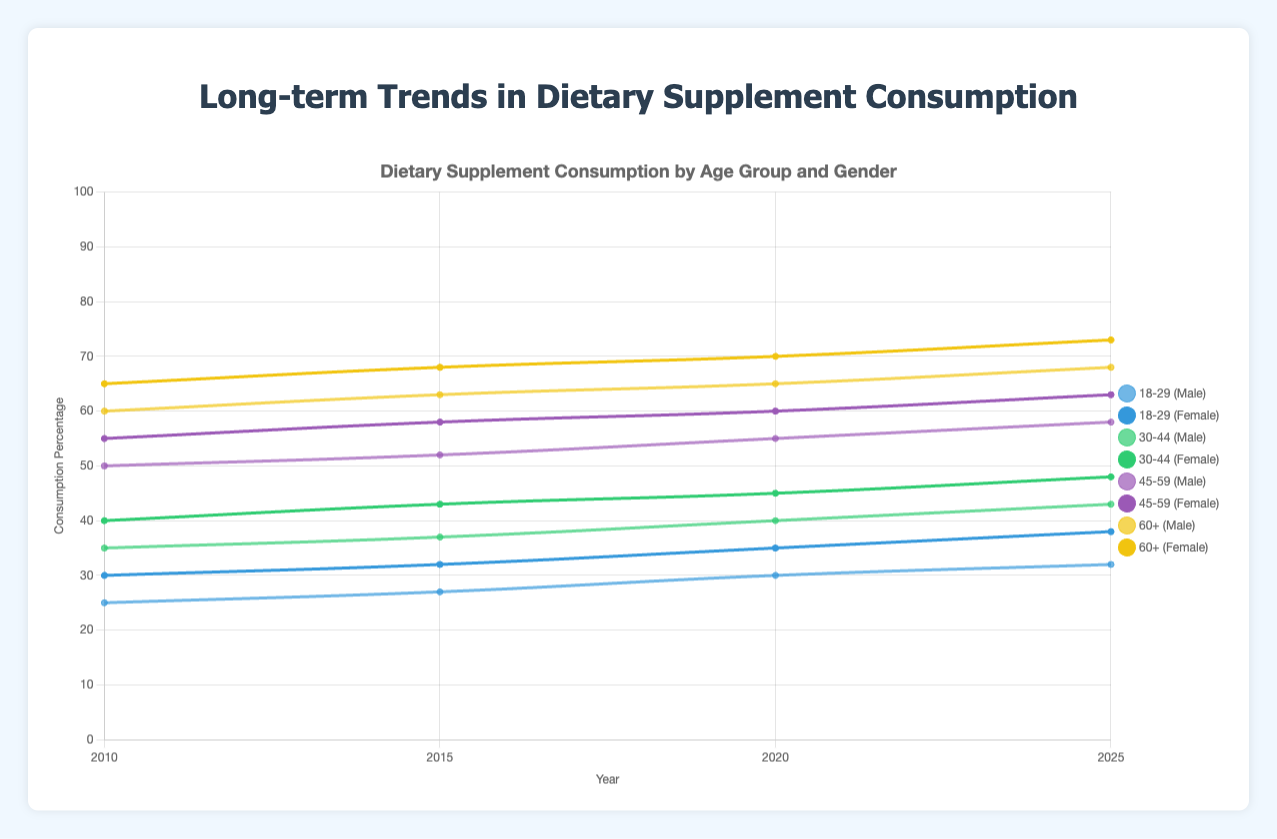Which gender showed the highest consumption percentage for the 60+ age group in 2020? Look at the 2020 data points for the 60+ age group. For males, the percentage is 65%, and for females, it is 70%.
Answer: Female By how many percentage points did dietary supplement consumption increase for the 18-29 age group males from 2010 to 2025? Find the consumption percentage for 18-29 males in 2010 (25%) and 2025 (32%), then subtract the former from the latter: 32% - 25% = 7%.
Answer: 7 What is the average consumption percentage of dietary supplements for all age groups and genders in 2025? Average the 2025 consumption percentages for all entries: (32 + 38 + 43 + 48 + 58 + 63 + 68 + 73) / 8 = 53.125%
Answer: 53.125 Which age group showed the largest increase in dietary supplement consumption among females from 2010 to 2025? Calculate the increase for each age group for females and find the largest: 18-29 (38-30=8), 30-44 (48-40=8), 45-59 (63-55=8), 60+ (73-65=8). All age groups increased by 8%.
Answer: All equal Did the 45-59 age group for males ever show higher consumption percentages than the 60+ age group for males? Compare the consumption percentages for males in the 45-59 and 60+ age groups across all years. The 60+ group always has higher percentages than the 45-59 group.
Answer: No Which gender and age group had the lowest consumption percentage in 2010? The 2010 data points are: Male 18-29: 25%, Female 18-29: 30%, Male 30-44: 35%, Female 30-44: 40%, Male 45-59: 50%, Female 45-59: 55%, Male 60+: 60%, Female 60+: 65%. The lowest is Male 18-29 at 25%.
Answer: Male 18-29 By what percentage did dietary supplement consumption for the 30-44 age group females change from 2015 to 2020? Find the consumption percentage for 30-44 females in 2015 (43%) and 2020 (45%). The change is 45% - 43% = 2%.
Answer: 2 Which year had the highest overall dietary supplement consumption average across all age groups and genders? Calculate the average consumption percentage for each year and compare: 2010: 41.25%, 2015: 45.75%, 2020: 50.875%, 2025: 53.125%. The highest is 2025.
Answer: 2025 For the year 2025, which age group showed the smallest difference in supplement consumption between males and females? Calculate the difference for each age group in 2025: 18-29 (6%), 30-44 (5%), 45-59 (5%), 60+ (5%). The smallest difference is for 30-44, 45-59, and 60+ which all have 5%.
Answer: 30-44, 45-59, 60+ Which age group had the highest increase in dietary supplement consumption from 2010 to 2025 for males? Calculate the increase for each age group for males: 18-29 (32%-25% = 7%), 30-44 (43%-35% = 8%), 45-59 (58%-50% = 8%), 60+ (68%-60% = 8%). The highest increase is 8%.
Answer: 30-44, 45-59, 60+ 